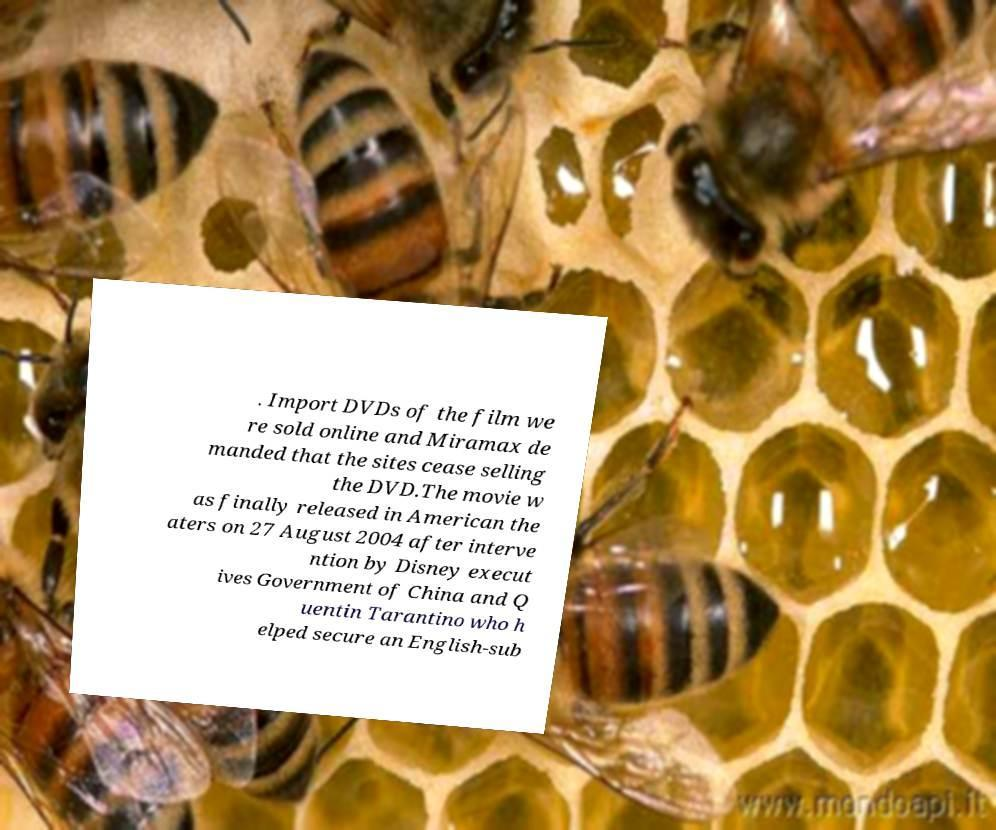What messages or text are displayed in this image? I need them in a readable, typed format. . Import DVDs of the film we re sold online and Miramax de manded that the sites cease selling the DVD.The movie w as finally released in American the aters on 27 August 2004 after interve ntion by Disney execut ives Government of China and Q uentin Tarantino who h elped secure an English-sub 